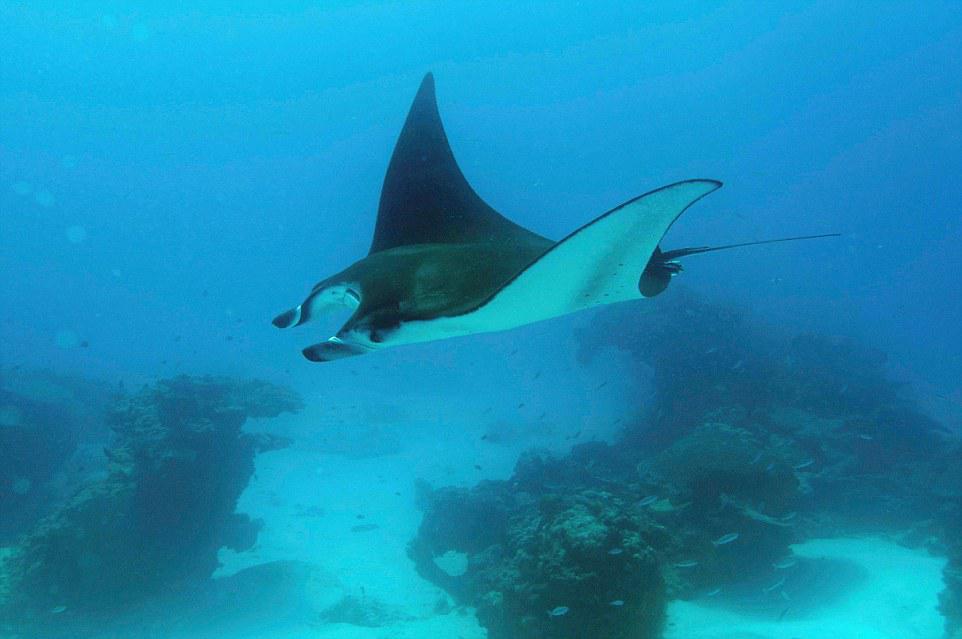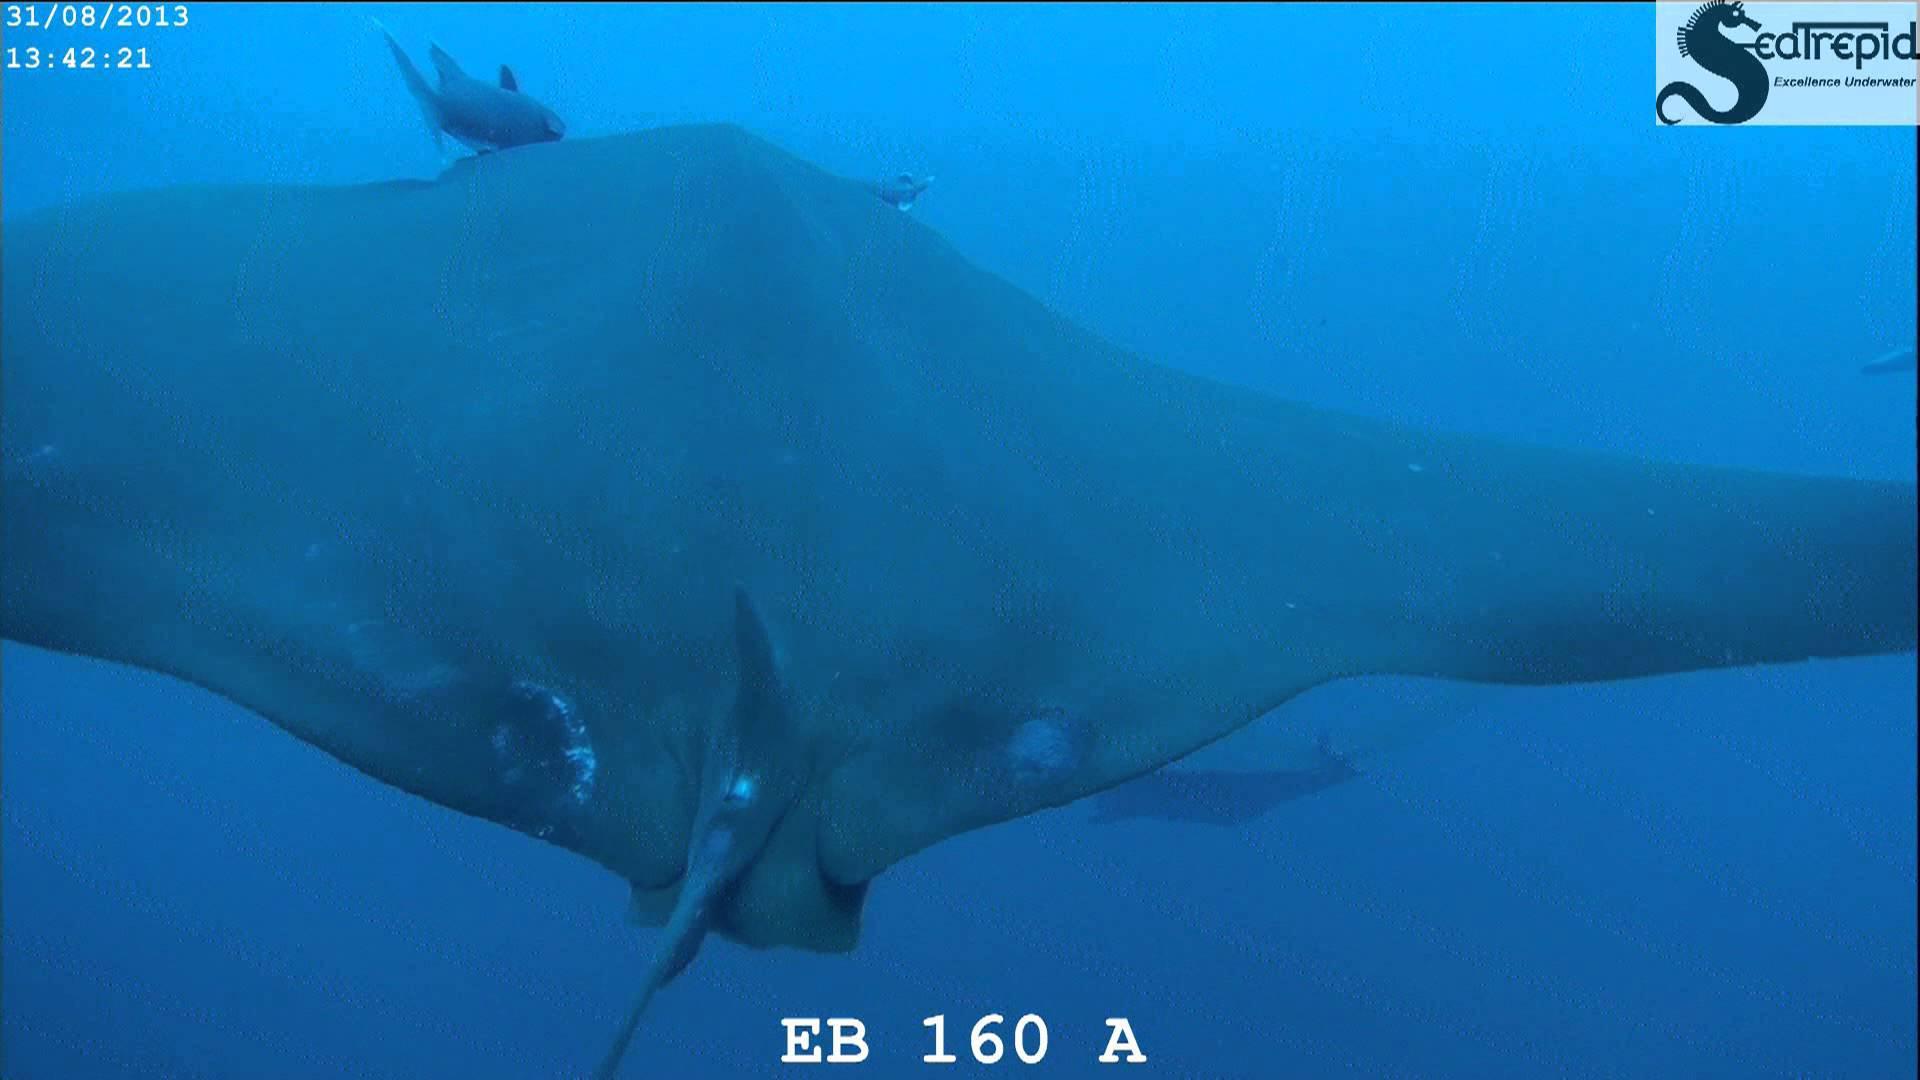The first image is the image on the left, the second image is the image on the right. Examine the images to the left and right. Is the description "There is exactly one stingray in the image on the left." accurate? Answer yes or no. Yes. The first image is the image on the left, the second image is the image on the right. For the images shown, is this caption "One image contains dozens of stingrays swimming close together." true? Answer yes or no. No. 